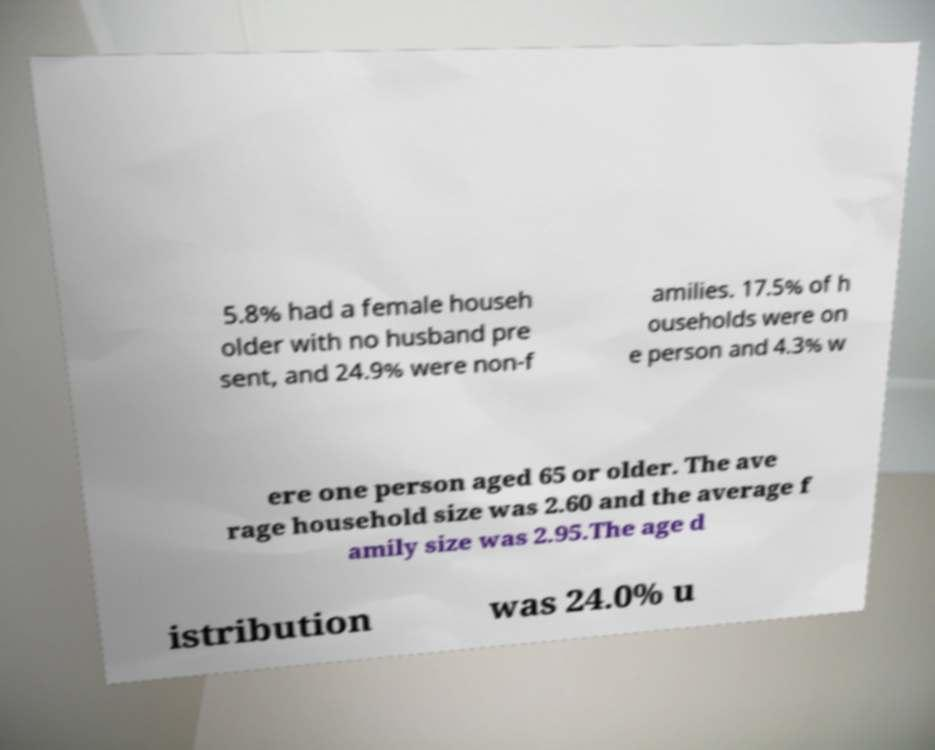Can you accurately transcribe the text from the provided image for me? 5.8% had a female househ older with no husband pre sent, and 24.9% were non-f amilies. 17.5% of h ouseholds were on e person and 4.3% w ere one person aged 65 or older. The ave rage household size was 2.60 and the average f amily size was 2.95.The age d istribution was 24.0% u 